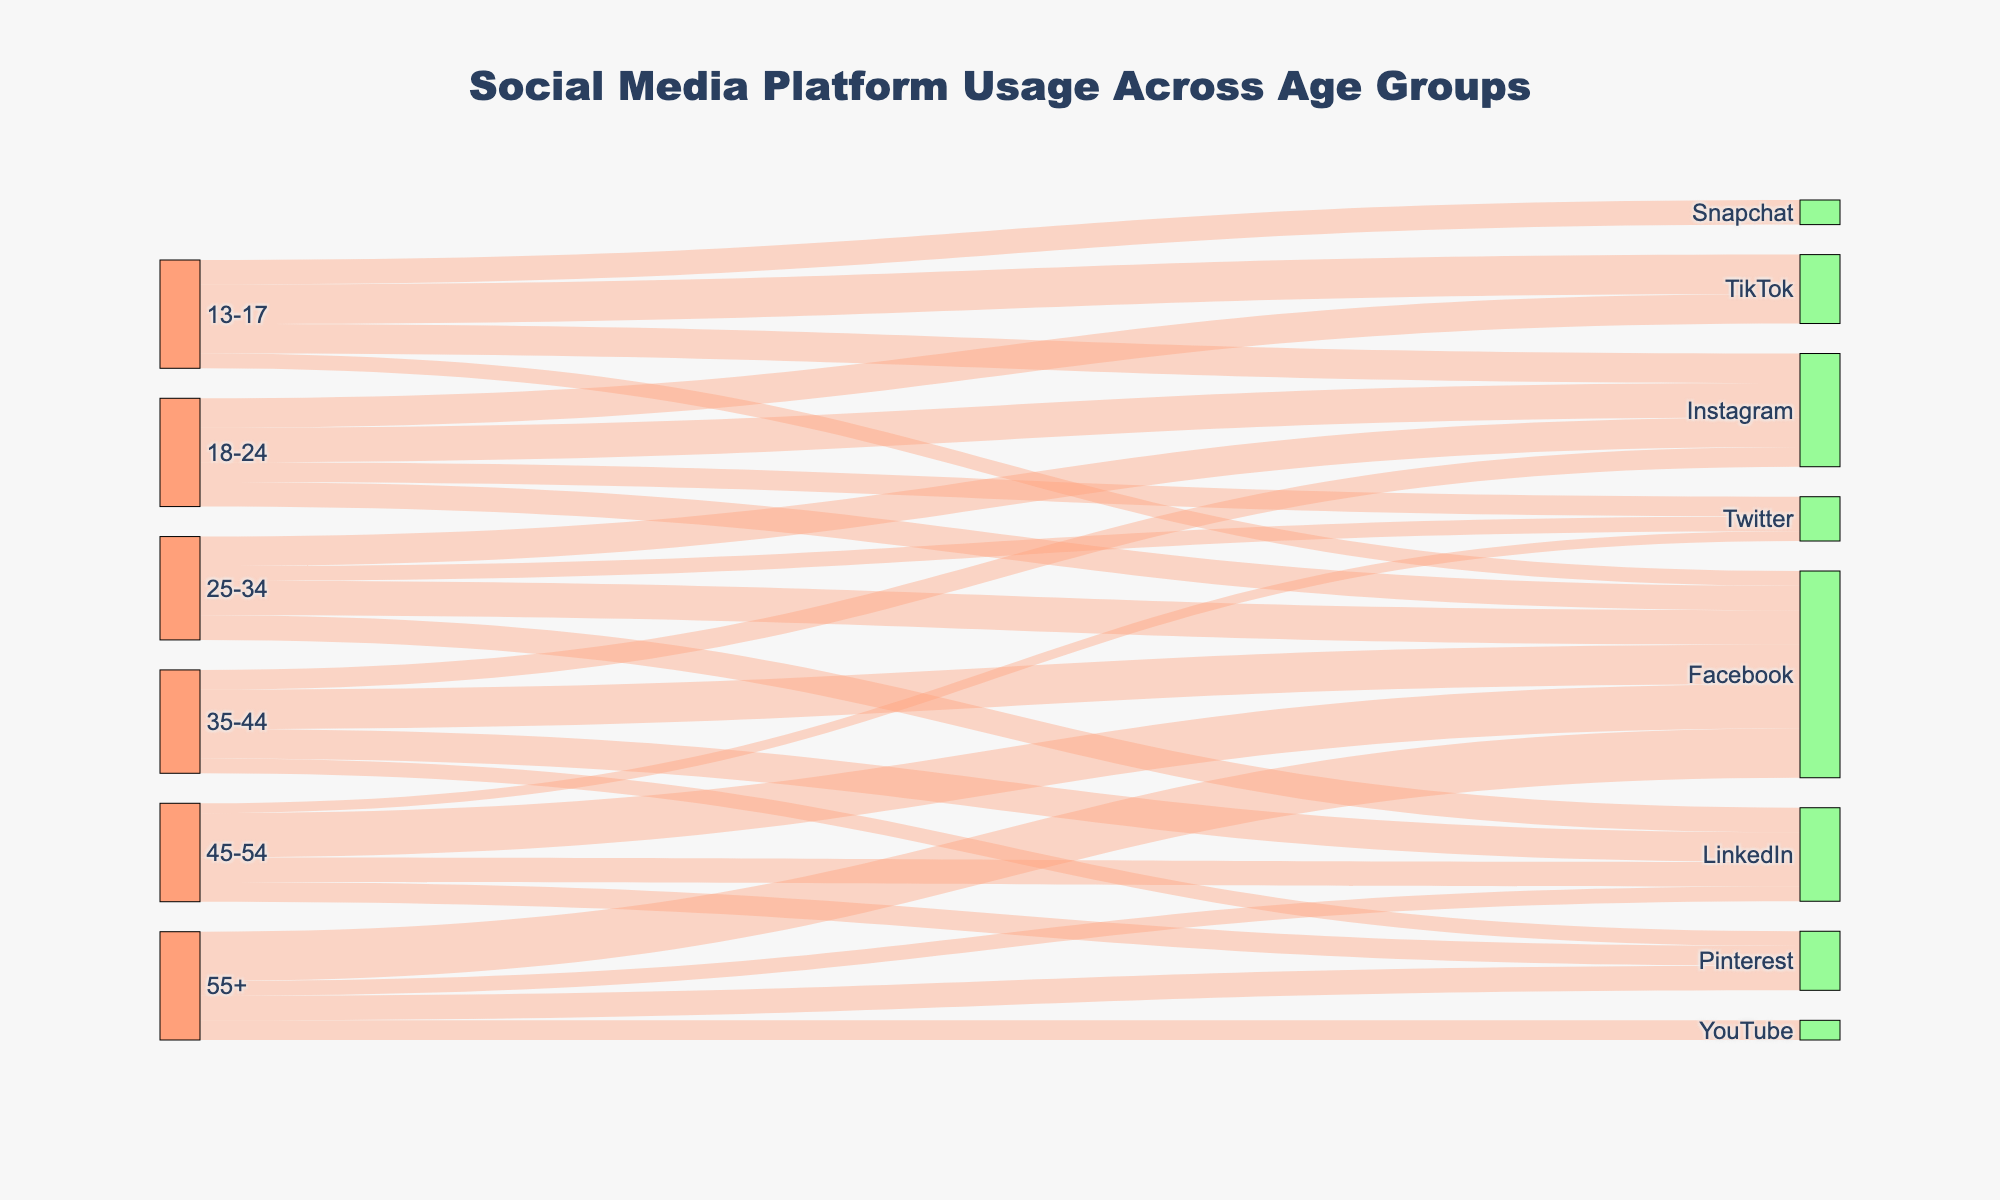What is the title of the figure? The title is located at the top-center of the figure and is the most prominent text. It summarizes the main content of the figure.
Answer: Social Media Platform Usage Across Age Groups How many age groups are represented in the figure? Count the unique age group labels on the left side of the Sankey diagram.
Answer: 6 Which social media platform is most commonly used by the 13-17 age group? Look for the largest flow from the 13-17 age group to a target platform. The thickness of the flow represents the value.
Answer: TikTok Which social media platform has the most connections across all age groups? Count the number of flows entering each social media platform. The platform with the highest count is the most connected.
Answer: Facebook What is the total usage value of Instagram across all age groups? Sum the values of flows entering Instagram from all age groups.
Answer: 115 Which age group has the highest usage for Facebook? Identify the largest flow entering Facebook. Check the source age group for this flow.
Answer: 55+ How does the usage of Twitter compare between the 18-24 and 25-34 age groups? Compare the values of flows from the 18-24 and 25-34 age groups to Twitter.
Answer: Twitter usage for 18-24 is higher than for 25-34 Which age groups use LinkedIn? Identify all age groups that have flows leading to LinkedIn.
Answer: 25-34, 35-44, 45-54, 55+ Total usage value for age group 45-54 across all platforms? Sum the values of all flows originating from the 45-54 age group.
Answer: 100 What proportion of the 35-44 age group's social media usage is dedicated to Facebook? Divide the value of the flow from 35-44 to Facebook by the total value of all flows from the 35-44 age group, then multiply by 100 to get the percentage.
Answer: 40% 